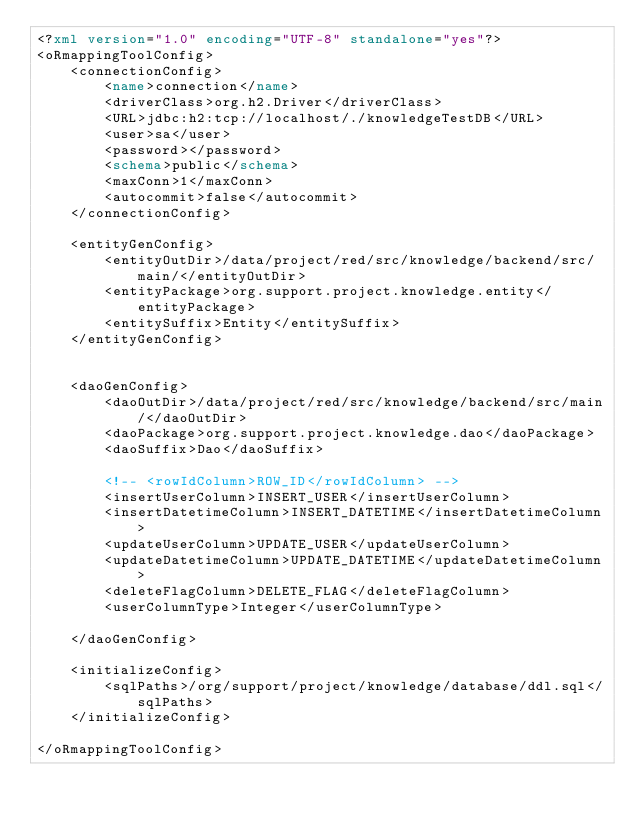<code> <loc_0><loc_0><loc_500><loc_500><_XML_><?xml version="1.0" encoding="UTF-8" standalone="yes"?>
<oRmappingToolConfig>
    <connectionConfig>
        <name>connection</name>
        <driverClass>org.h2.Driver</driverClass>
        <URL>jdbc:h2:tcp://localhost/./knowledgeTestDB</URL>
        <user>sa</user>
        <password></password>
        <schema>public</schema>
        <maxConn>1</maxConn>
        <autocommit>false</autocommit>
    </connectionConfig>

    <entityGenConfig>
        <entityOutDir>/data/project/red/src/knowledge/backend/src/main/</entityOutDir>
        <entityPackage>org.support.project.knowledge.entity</entityPackage>
        <entitySuffix>Entity</entitySuffix>
    </entityGenConfig>


    <daoGenConfig>
        <daoOutDir>/data/project/red/src/knowledge/backend/src/main/</daoOutDir>
        <daoPackage>org.support.project.knowledge.dao</daoPackage>
        <daoSuffix>Dao</daoSuffix>

        <!-- <rowIdColumn>ROW_ID</rowIdColumn> -->
        <insertUserColumn>INSERT_USER</insertUserColumn>
        <insertDatetimeColumn>INSERT_DATETIME</insertDatetimeColumn>
        <updateUserColumn>UPDATE_USER</updateUserColumn>
        <updateDatetimeColumn>UPDATE_DATETIME</updateDatetimeColumn>
        <deleteFlagColumn>DELETE_FLAG</deleteFlagColumn>
        <userColumnType>Integer</userColumnType>

    </daoGenConfig>

    <initializeConfig>
        <sqlPaths>/org/support/project/knowledge/database/ddl.sql</sqlPaths>
    </initializeConfig>

</oRmappingToolConfig></code> 